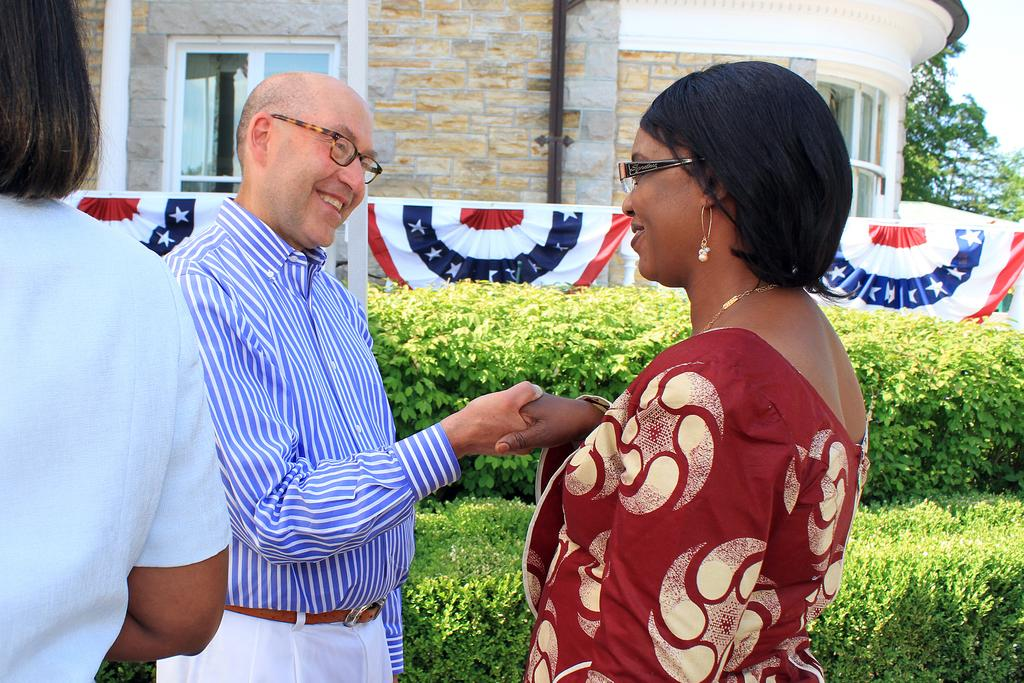What type of structure is present in the image? There is a house in the image. What feature can be seen on the house? The house has a window. How many people are in the image? There are three persons in the image. What else is present in the image besides the house and people? There are many plants in the image. What can be seen above the house and plants in the image? There is a sky visible in the image. What type of eggs can be seen in the image? There are no eggs present in the image. What title does the house have in the image? The image does not provide a title for the house. 